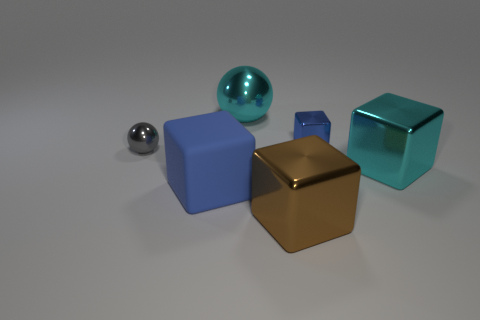Is there a thing of the same color as the tiny shiny cube?
Ensure brevity in your answer.  Yes. There is a rubber thing that is the same color as the tiny cube; what shape is it?
Give a very brief answer. Cube. The tiny sphere that is behind the big block that is to the right of the tiny thing that is to the right of the gray ball is made of what material?
Offer a terse response. Metal. What is the material of the large brown object that is the same shape as the tiny blue shiny thing?
Your response must be concise. Metal. What is the size of the object left of the blue object to the left of the big cyan object to the left of the cyan block?
Your response must be concise. Small. Does the rubber object have the same size as the cyan metal ball?
Offer a terse response. Yes. What material is the large block that is behind the blue thing to the left of the brown cube?
Your response must be concise. Metal. Do the blue thing that is to the right of the blue rubber cube and the tiny shiny object that is left of the brown object have the same shape?
Ensure brevity in your answer.  No. Is the number of brown cubes that are left of the large brown cube the same as the number of matte cubes?
Provide a short and direct response. No. There is a blue cube right of the cyan ball; is there a big blue matte cube that is left of it?
Provide a short and direct response. Yes. 